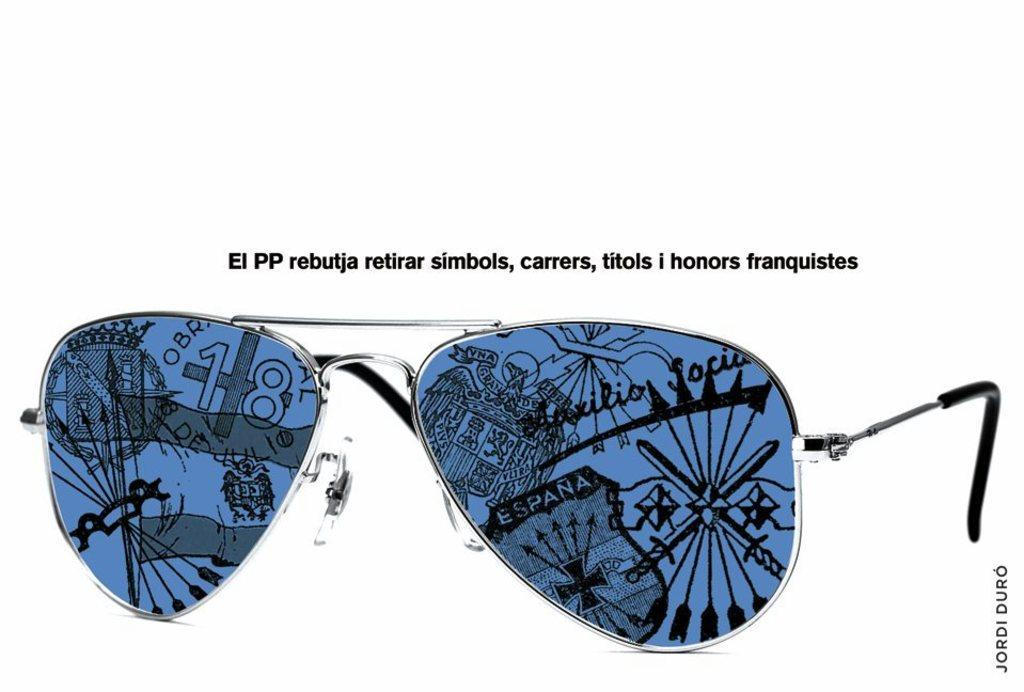What is located on the platform in the image? There is a pair of goggles on a platform in the image. Are there any other objects on the platform? Yes, there are objects on the platform. What can be seen on the platform besides the objects? There is text on the platform. What type of lip can be seen on the platform in the image? There is no lip present on the platform in the image. 